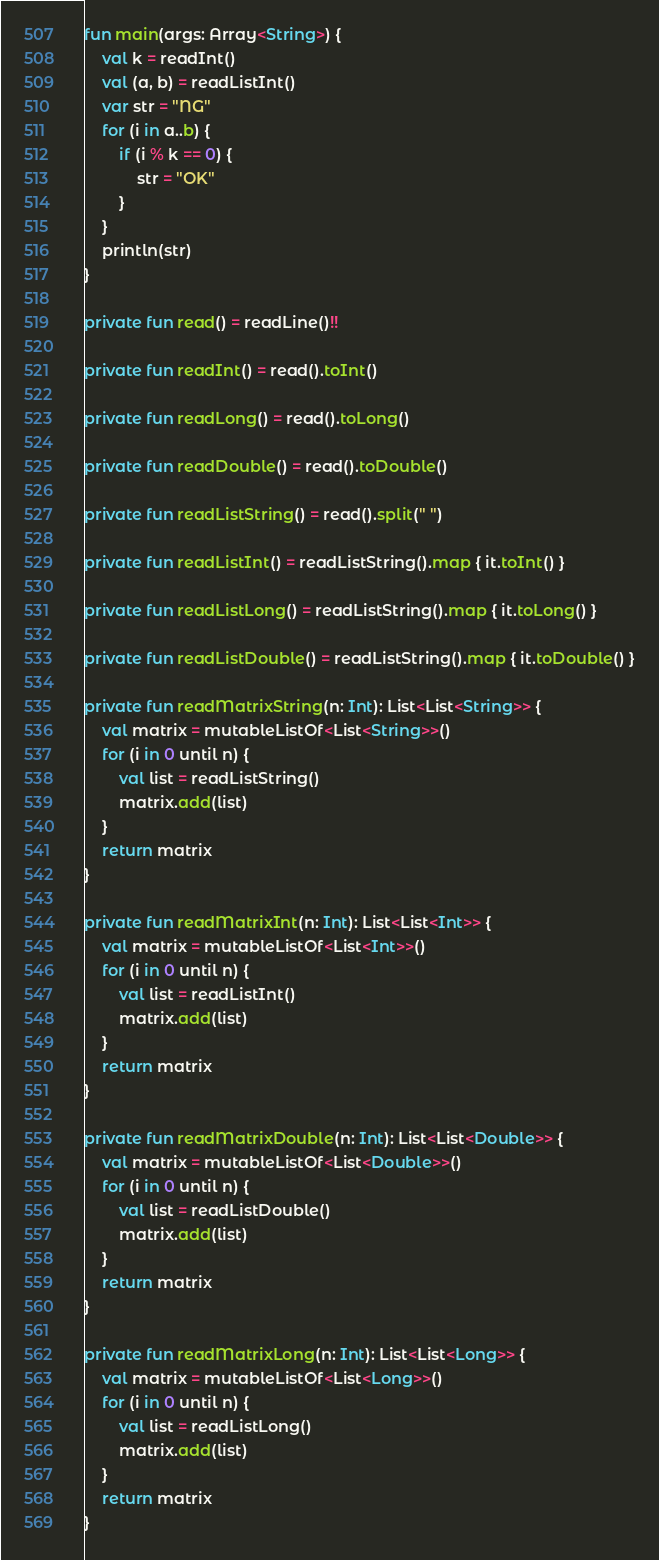<code> <loc_0><loc_0><loc_500><loc_500><_Kotlin_>fun main(args: Array<String>) {
    val k = readInt()
    val (a, b) = readListInt()
    var str = "NG"
    for (i in a..b) {
        if (i % k == 0) {
            str = "OK"
        }
    }
    println(str)
}

private fun read() = readLine()!!

private fun readInt() = read().toInt()

private fun readLong() = read().toLong()

private fun readDouble() = read().toDouble()

private fun readListString() = read().split(" ")

private fun readListInt() = readListString().map { it.toInt() }

private fun readListLong() = readListString().map { it.toLong() }

private fun readListDouble() = readListString().map { it.toDouble() }

private fun readMatrixString(n: Int): List<List<String>> {
    val matrix = mutableListOf<List<String>>()
    for (i in 0 until n) {
        val list = readListString()
        matrix.add(list)
    }
    return matrix
}

private fun readMatrixInt(n: Int): List<List<Int>> {
    val matrix = mutableListOf<List<Int>>()
    for (i in 0 until n) {
        val list = readListInt()
        matrix.add(list)
    }
    return matrix
}

private fun readMatrixDouble(n: Int): List<List<Double>> {
    val matrix = mutableListOf<List<Double>>()
    for (i in 0 until n) {
        val list = readListDouble()
        matrix.add(list)
    }
    return matrix
}

private fun readMatrixLong(n: Int): List<List<Long>> {
    val matrix = mutableListOf<List<Long>>()
    for (i in 0 until n) {
        val list = readListLong()
        matrix.add(list)
    }
    return matrix
}

</code> 